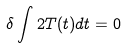<formula> <loc_0><loc_0><loc_500><loc_500>\delta \int 2 T ( t ) d t = 0</formula> 